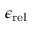<formula> <loc_0><loc_0><loc_500><loc_500>{ \epsilon _ { r e l } }</formula> 